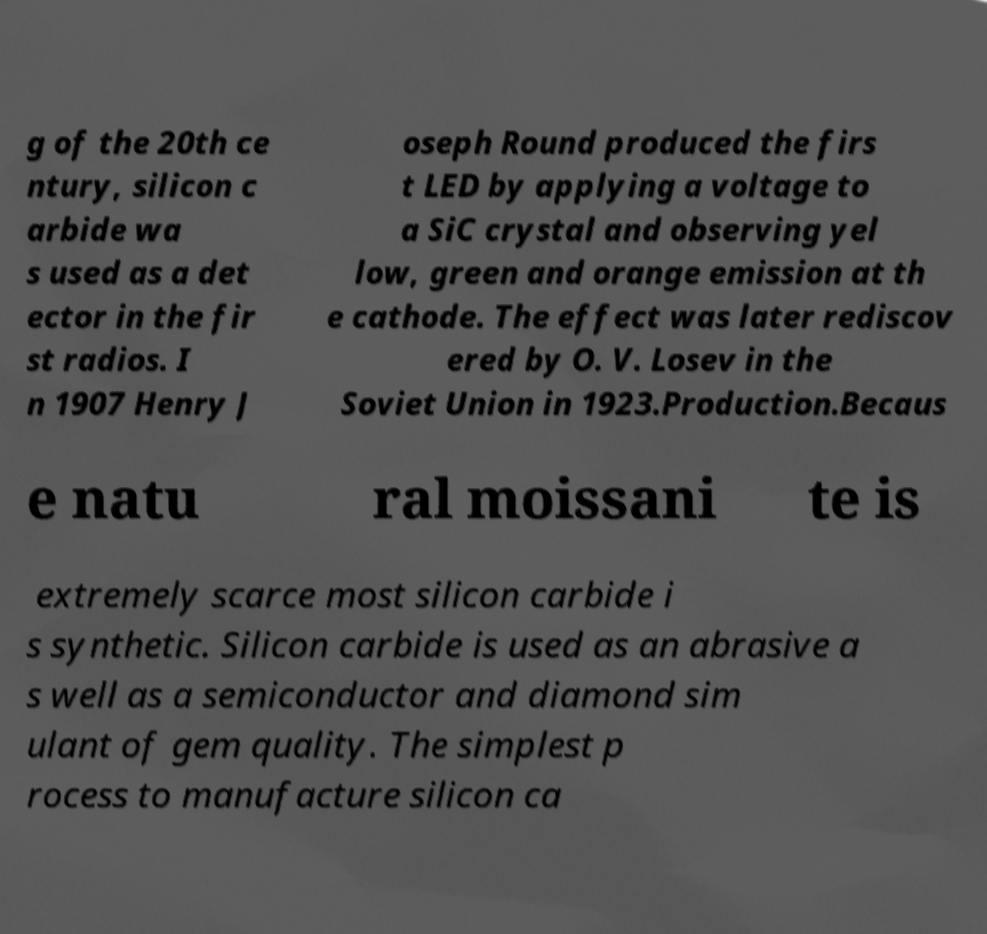Could you extract and type out the text from this image? g of the 20th ce ntury, silicon c arbide wa s used as a det ector in the fir st radios. I n 1907 Henry J oseph Round produced the firs t LED by applying a voltage to a SiC crystal and observing yel low, green and orange emission at th e cathode. The effect was later rediscov ered by O. V. Losev in the Soviet Union in 1923.Production.Becaus e natu ral moissani te is extremely scarce most silicon carbide i s synthetic. Silicon carbide is used as an abrasive a s well as a semiconductor and diamond sim ulant of gem quality. The simplest p rocess to manufacture silicon ca 